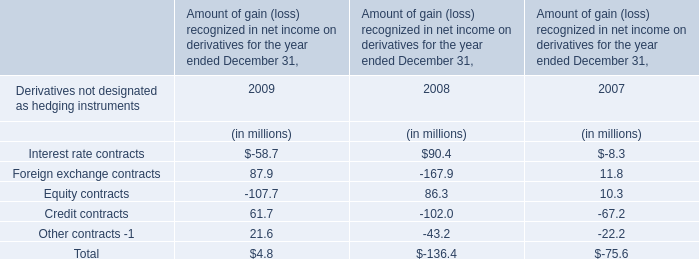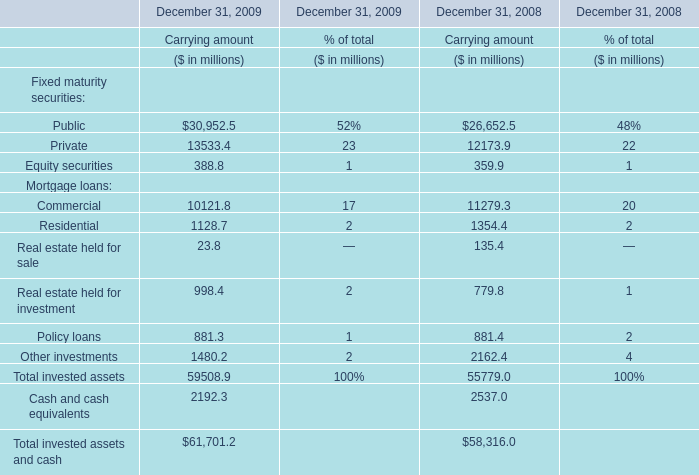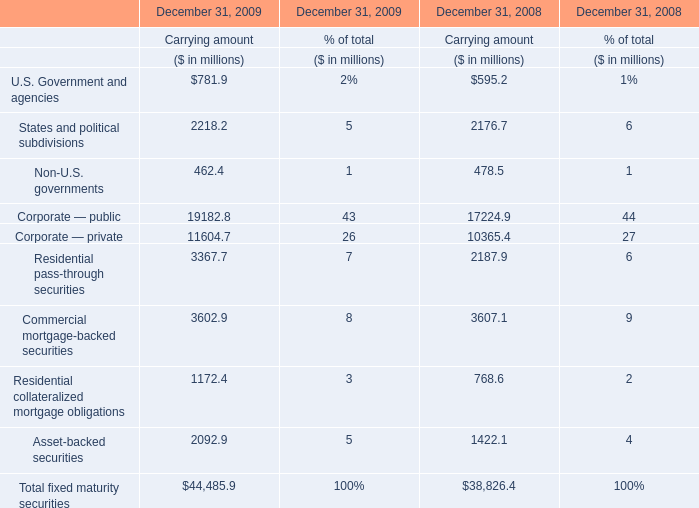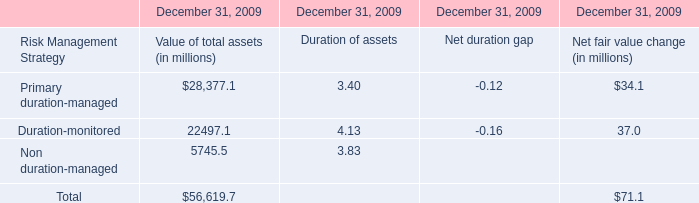What's the greatest value of Mortgage loans in 2009? 
Answer: commercial. 